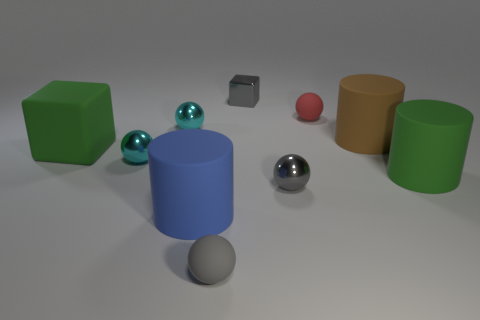There is a large thing that is both behind the large green cylinder and right of the small red matte thing; what is its color?
Make the answer very short. Brown. Is there a small cyan block made of the same material as the green cube?
Your response must be concise. No. What size is the green cube?
Your response must be concise. Large. What size is the metallic sphere to the right of the small object that is behind the tiny red rubber object?
Offer a terse response. Small. What is the material of the green object that is the same shape as the big blue thing?
Your answer should be very brief. Rubber. How many tiny green matte objects are there?
Your answer should be very brief. 0. The matte cylinder behind the big green object that is to the right of the rubber ball that is in front of the green matte block is what color?
Ensure brevity in your answer.  Brown. Are there fewer big gray metal objects than small metallic objects?
Offer a very short reply. Yes. What is the color of the other matte object that is the same shape as the gray matte thing?
Provide a short and direct response. Red. What is the color of the big cube that is made of the same material as the brown thing?
Provide a short and direct response. Green. 